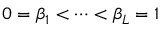<formula> <loc_0><loc_0><loc_500><loc_500>0 = \beta _ { 1 } < \cdots < \beta _ { L } = 1</formula> 